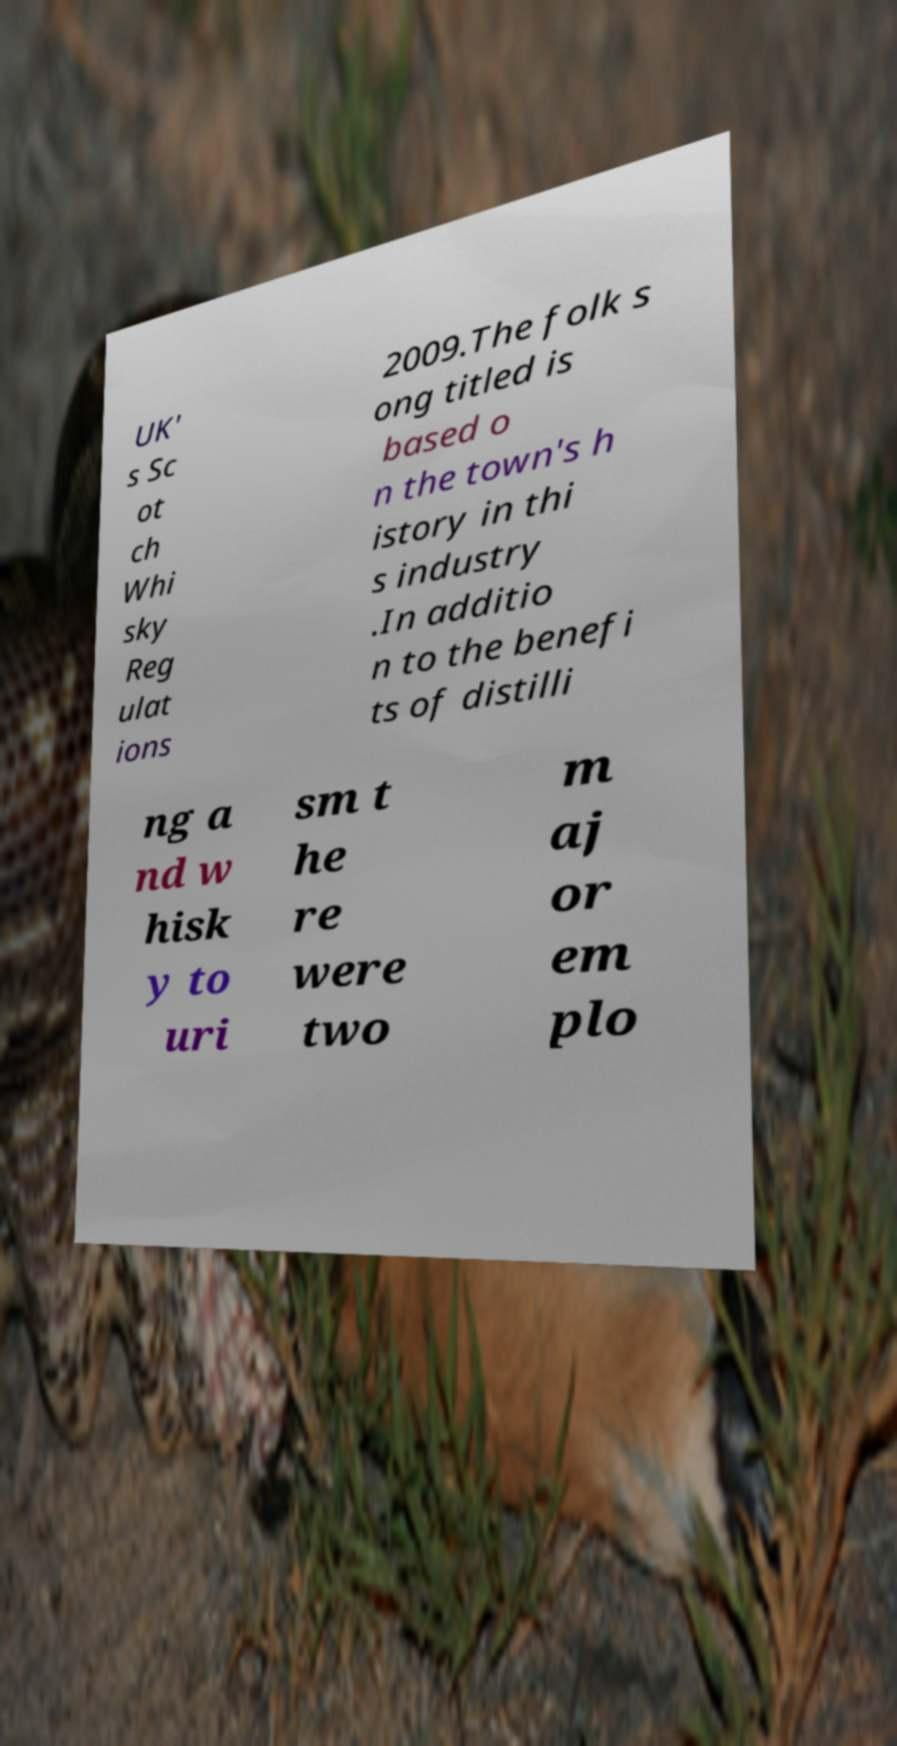Could you extract and type out the text from this image? UK' s Sc ot ch Whi sky Reg ulat ions 2009.The folk s ong titled is based o n the town's h istory in thi s industry .In additio n to the benefi ts of distilli ng a nd w hisk y to uri sm t he re were two m aj or em plo 